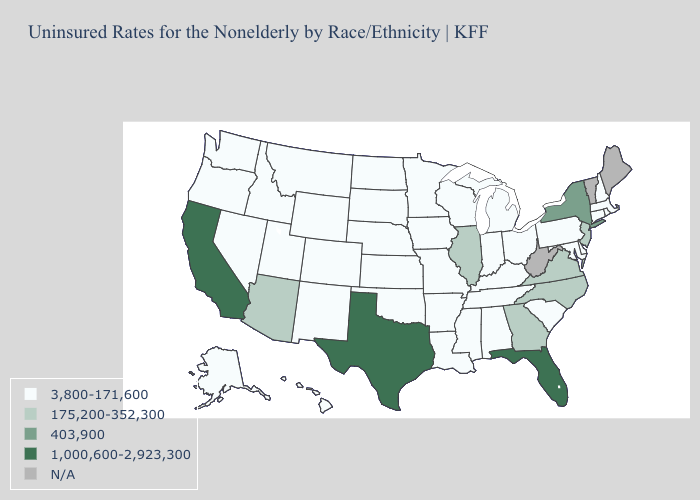How many symbols are there in the legend?
Short answer required. 5. Name the states that have a value in the range N/A?
Answer briefly. Maine, Vermont, West Virginia. Among the states that border Missouri , which have the lowest value?
Give a very brief answer. Arkansas, Iowa, Kansas, Kentucky, Nebraska, Oklahoma, Tennessee. Which states hav the highest value in the West?
Write a very short answer. California. Which states hav the highest value in the Northeast?
Answer briefly. New York. Does the map have missing data?
Give a very brief answer. Yes. What is the lowest value in states that border South Dakota?
Concise answer only. 3,800-171,600. What is the lowest value in the MidWest?
Write a very short answer. 3,800-171,600. Name the states that have a value in the range 175,200-352,300?
Answer briefly. Arizona, Georgia, Illinois, New Jersey, North Carolina, Virginia. Is the legend a continuous bar?
Answer briefly. No. Name the states that have a value in the range 403,900?
Write a very short answer. New York. What is the value of Wyoming?
Quick response, please. 3,800-171,600. Name the states that have a value in the range 1,000,600-2,923,300?
Short answer required. California, Florida, Texas. Does California have the lowest value in the USA?
Write a very short answer. No. 